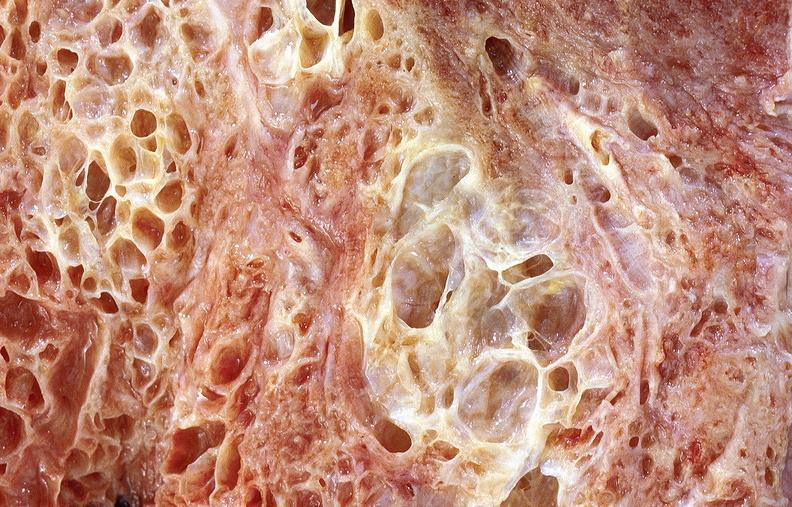s respiratory present?
Answer the question using a single word or phrase. Yes 